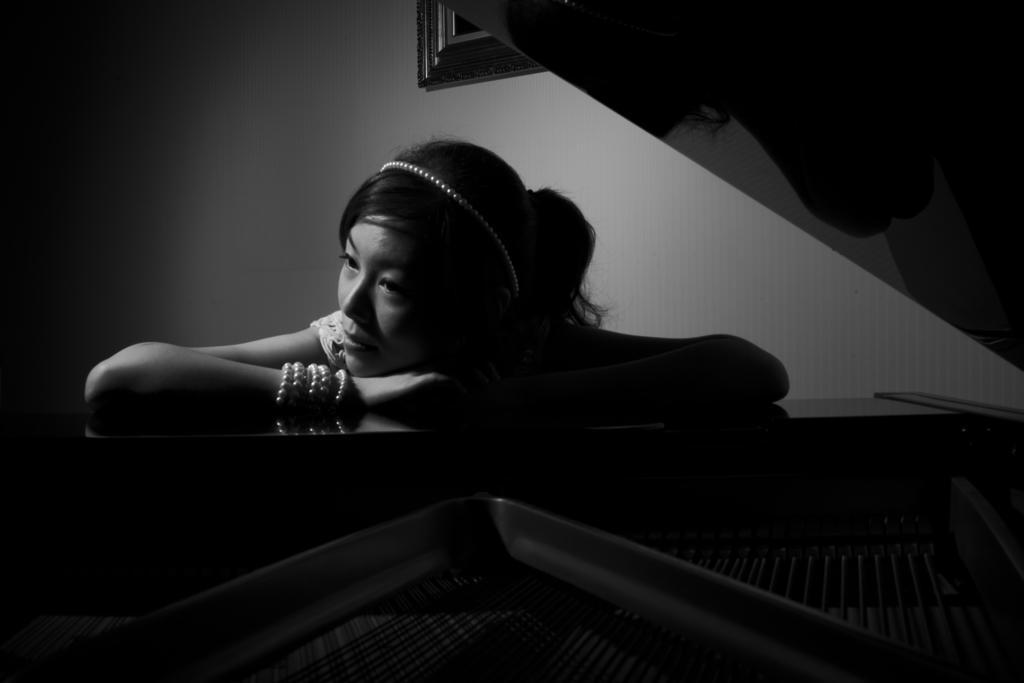Could you give a brief overview of what you see in this image? In this picture there is a woman who is wearing a bracelet, white dress and she is sitting near to the piano. At the top there is a frame which is placed on the wall. 